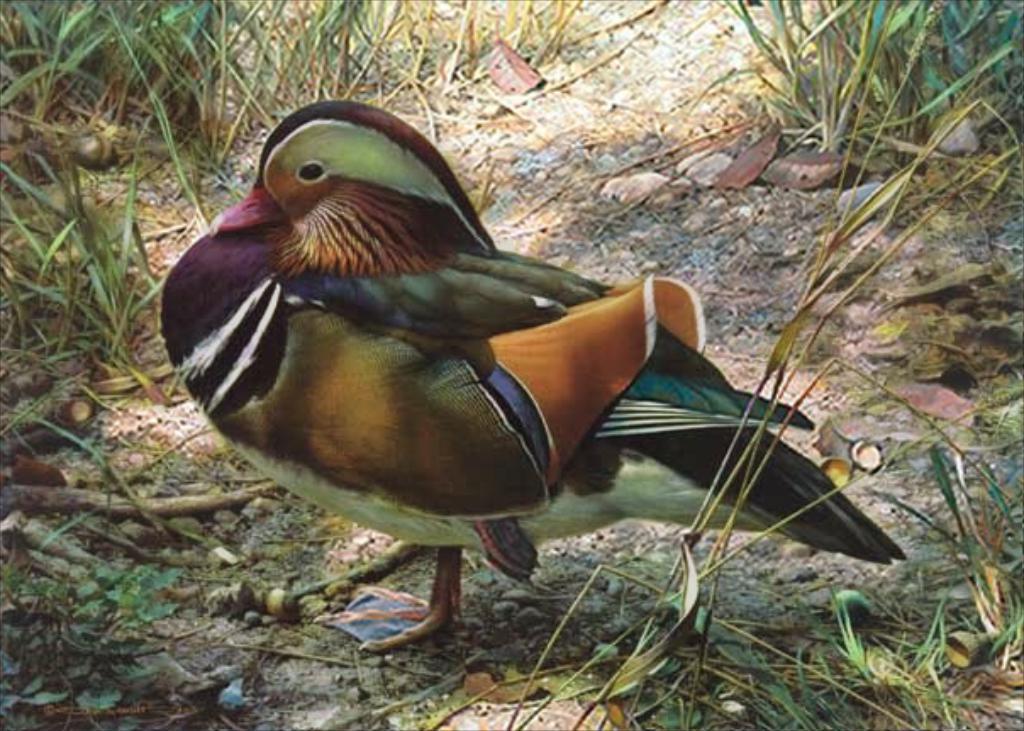In one or two sentences, can you explain what this image depicts? In this image there is a bird standing on the ground around that there is so much of grass. 